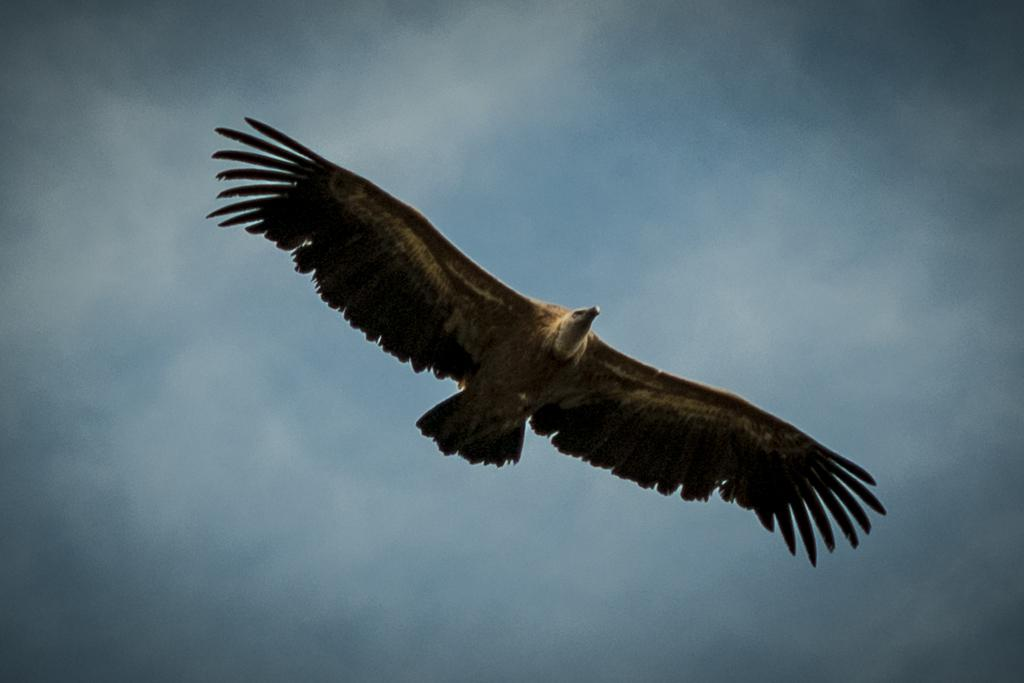What animal is the main subject of the picture? There is an eagle in the picture. What is the eagle doing in the image? The eagle is flying in the air. How would you describe the sky in the picture? The sky is cloudy. What type of frame is around the eagle in the image? There is no frame around the eagle in the image; it is a photograph or illustration of the eagle in its natural environment. What is the weather like in the image? The provided facts only mention that the sky is cloudy, but they do not specify the weather conditions. 